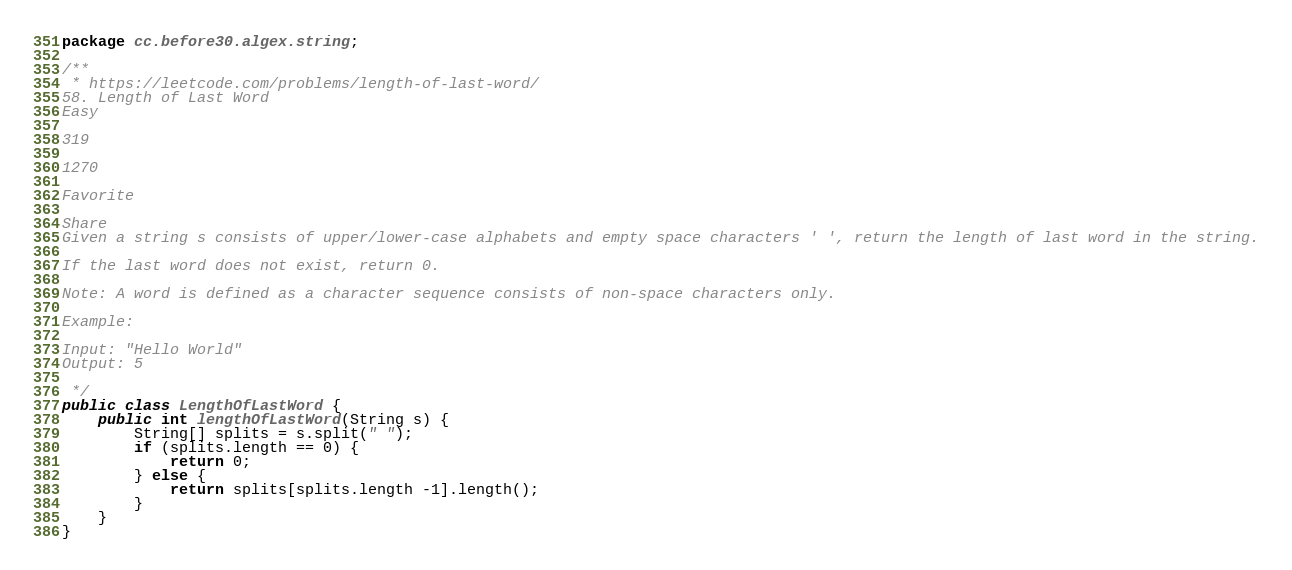Convert code to text. <code><loc_0><loc_0><loc_500><loc_500><_Java_>package cc.before30.algex.string;

/**
 * https://leetcode.com/problems/length-of-last-word/
58. Length of Last Word
Easy

319

1270

Favorite

Share
Given a string s consists of upper/lower-case alphabets and empty space characters ' ', return the length of last word in the string.

If the last word does not exist, return 0.

Note: A word is defined as a character sequence consists of non-space characters only.

Example:

Input: "Hello World"
Output: 5

 */
public class LengthOfLastWord {
    public int lengthOfLastWord(String s) {
        String[] splits = s.split(" ");
        if (splits.length == 0) {
            return 0;
        } else {
            return splits[splits.length -1].length();
        }
    }
}
</code> 